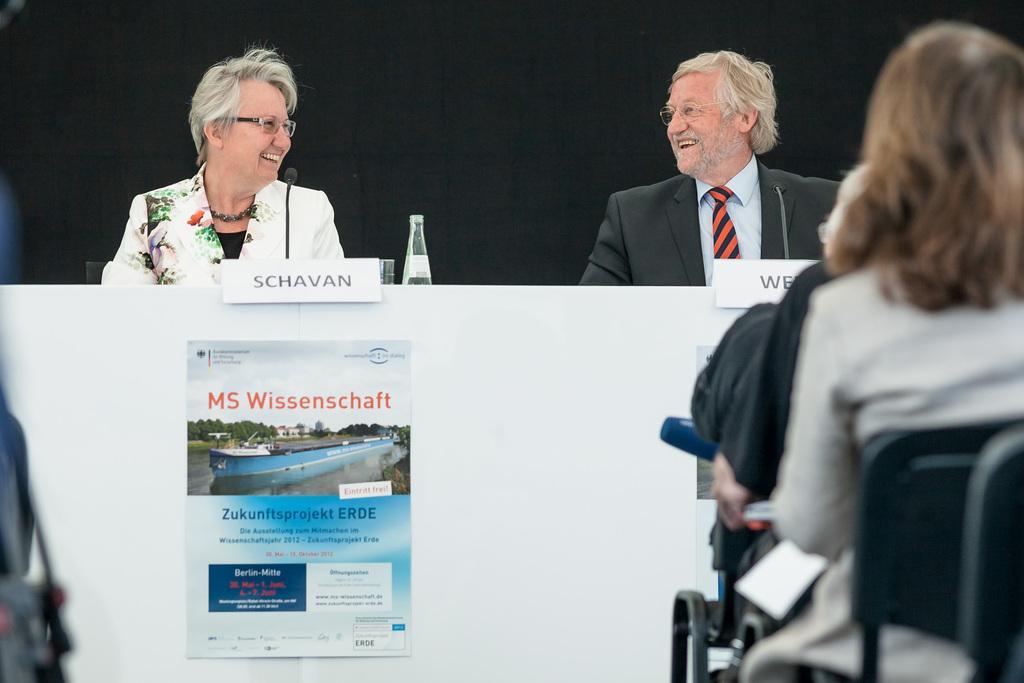Can you describe this image briefly? On the left side of the image we can see some object. On the right side of the image, we can see a few people are sitting on the chairs. In the center of the image, we can see two persons are sitting and they are smiling and they are wearing glasses. In front of them, there is a platform. On the platform, we can see one poster, name boards, one bottle, glass and a microphone. On the poster, we can see some text. And we can see the black color background. 